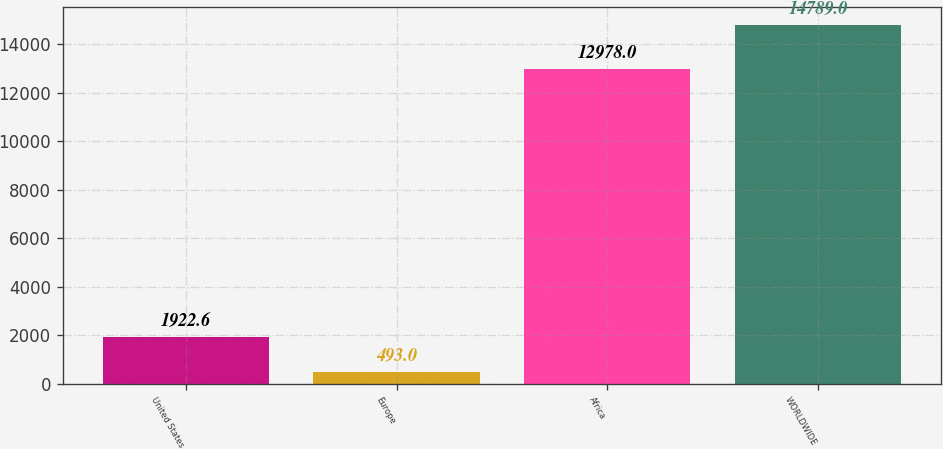Convert chart to OTSL. <chart><loc_0><loc_0><loc_500><loc_500><bar_chart><fcel>United States<fcel>Europe<fcel>Africa<fcel>WORLDWIDE<nl><fcel>1922.6<fcel>493<fcel>12978<fcel>14789<nl></chart> 